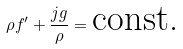Convert formula to latex. <formula><loc_0><loc_0><loc_500><loc_500>\rho f ^ { \prime } + \frac { j g } { \rho } = \text {const.}</formula> 